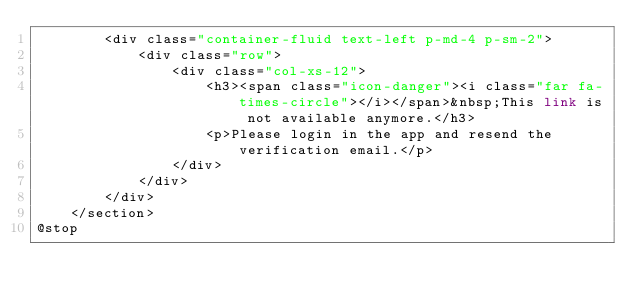Convert code to text. <code><loc_0><loc_0><loc_500><loc_500><_PHP_>        <div class="container-fluid text-left p-md-4 p-sm-2">
            <div class="row">
                <div class="col-xs-12">
                    <h3><span class="icon-danger"><i class="far fa-times-circle"></i></span>&nbsp;This link is not available anymore.</h3>
                    <p>Please login in the app and resend the verification email.</p>
                </div>
            </div>
        </div>
    </section>
@stop
</code> 